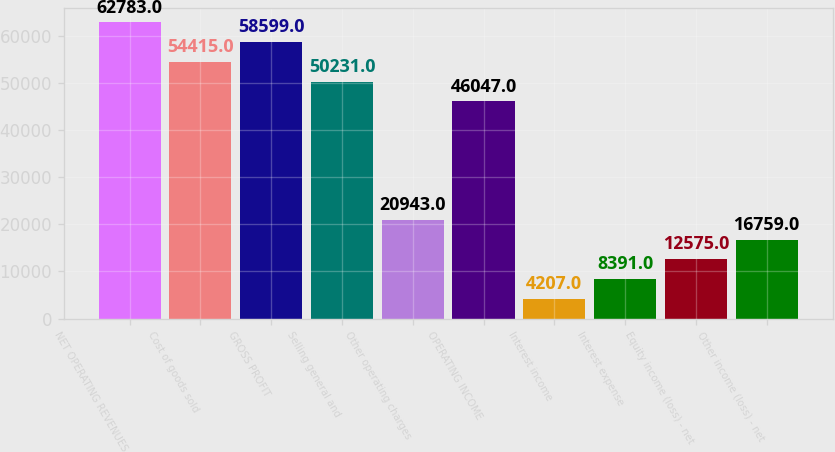Convert chart to OTSL. <chart><loc_0><loc_0><loc_500><loc_500><bar_chart><fcel>NET OPERATING REVENUES<fcel>Cost of goods sold<fcel>GROSS PROFIT<fcel>Selling general and<fcel>Other operating charges<fcel>OPERATING INCOME<fcel>Interest income<fcel>Interest expense<fcel>Equity income (loss) - net<fcel>Other income (loss) - net<nl><fcel>62783<fcel>54415<fcel>58599<fcel>50231<fcel>20943<fcel>46047<fcel>4207<fcel>8391<fcel>12575<fcel>16759<nl></chart> 